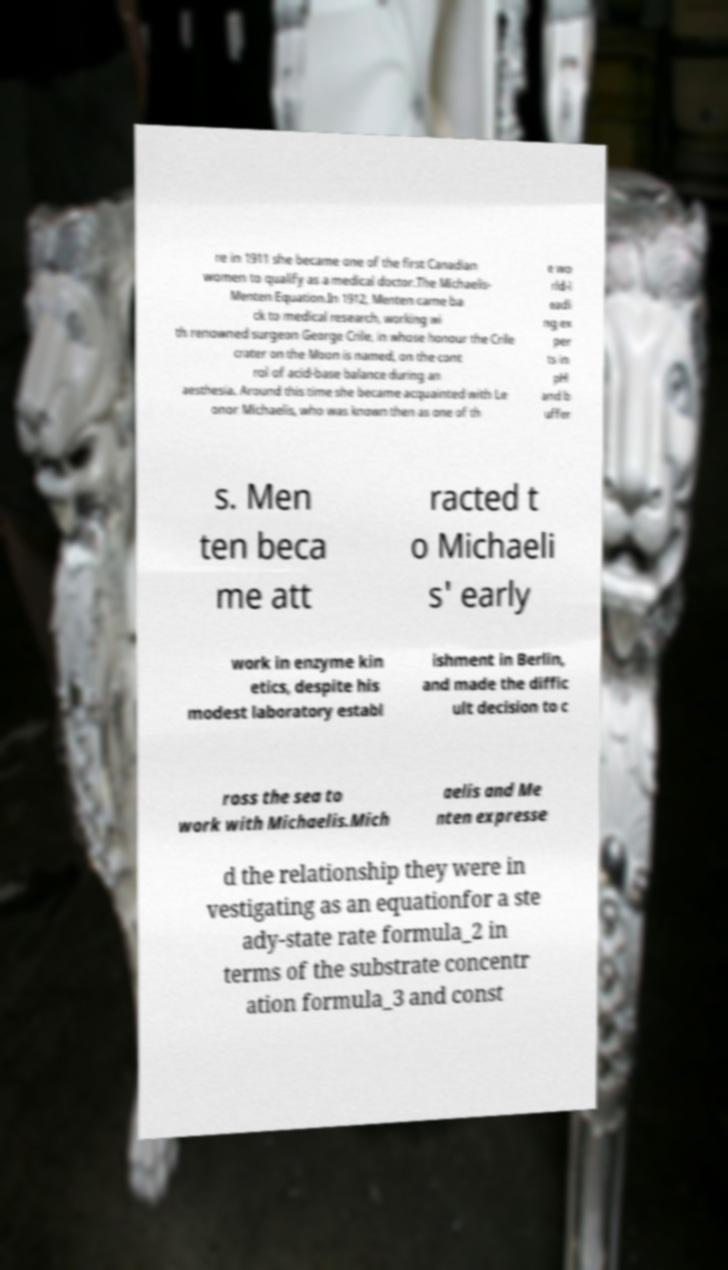For documentation purposes, I need the text within this image transcribed. Could you provide that? re in 1911 she became one of the first Canadian women to qualify as a medical doctor.The Michaelis- Menten Equation.In 1912, Menten came ba ck to medical research, working wi th renowned surgeon George Crile, in whose honour the Crile crater on the Moon is named, on the cont rol of acid-base balance during an aesthesia. Around this time she became acquainted with Le onor Michaelis, who was known then as one of th e wo rld-l eadi ng ex per ts in pH and b uffer s. Men ten beca me att racted t o Michaeli s' early work in enzyme kin etics, despite his modest laboratory establ ishment in Berlin, and made the diffic ult decision to c ross the sea to work with Michaelis.Mich aelis and Me nten expresse d the relationship they were in vestigating as an equationfor a ste ady-state rate formula_2 in terms of the substrate concentr ation formula_3 and const 